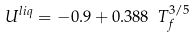Convert formula to latex. <formula><loc_0><loc_0><loc_500><loc_500>U ^ { l i q } = - 0 . 9 + 0 . 3 8 8 \ T _ { f } ^ { 3 / 5 }</formula> 